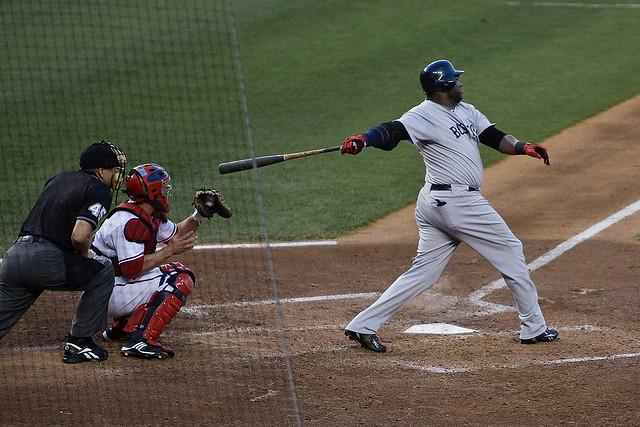Is he holding the bat with two hands?
Short answer required. No. What is in the catcher's right hand?
Answer briefly. Bat. What team does the batter play for?
Quick response, please. Boston. What is in the batters left hand?
Quick response, please. Nothing. Where on the field is this?
Answer briefly. Home plate. Is the man in the black shoes going to run the bases?
Give a very brief answer. Yes. Is this a professional ball team?
Be succinct. Yes. Which sport is this?
Write a very short answer. Baseball. Did the batter hit the ball?
Give a very brief answer. No. What color is the player's bat?
Quick response, please. Black. What team is at bat?
Write a very short answer. Boston. Was that a hit or strike?
Write a very short answer. Strike. Where  is the batter standing?
Quick response, please. Home plate. What color is the ground?
Concise answer only. Brown. What color is his helmet?
Concise answer only. Blue. Did the player hit the ball?
Give a very brief answer. No. 